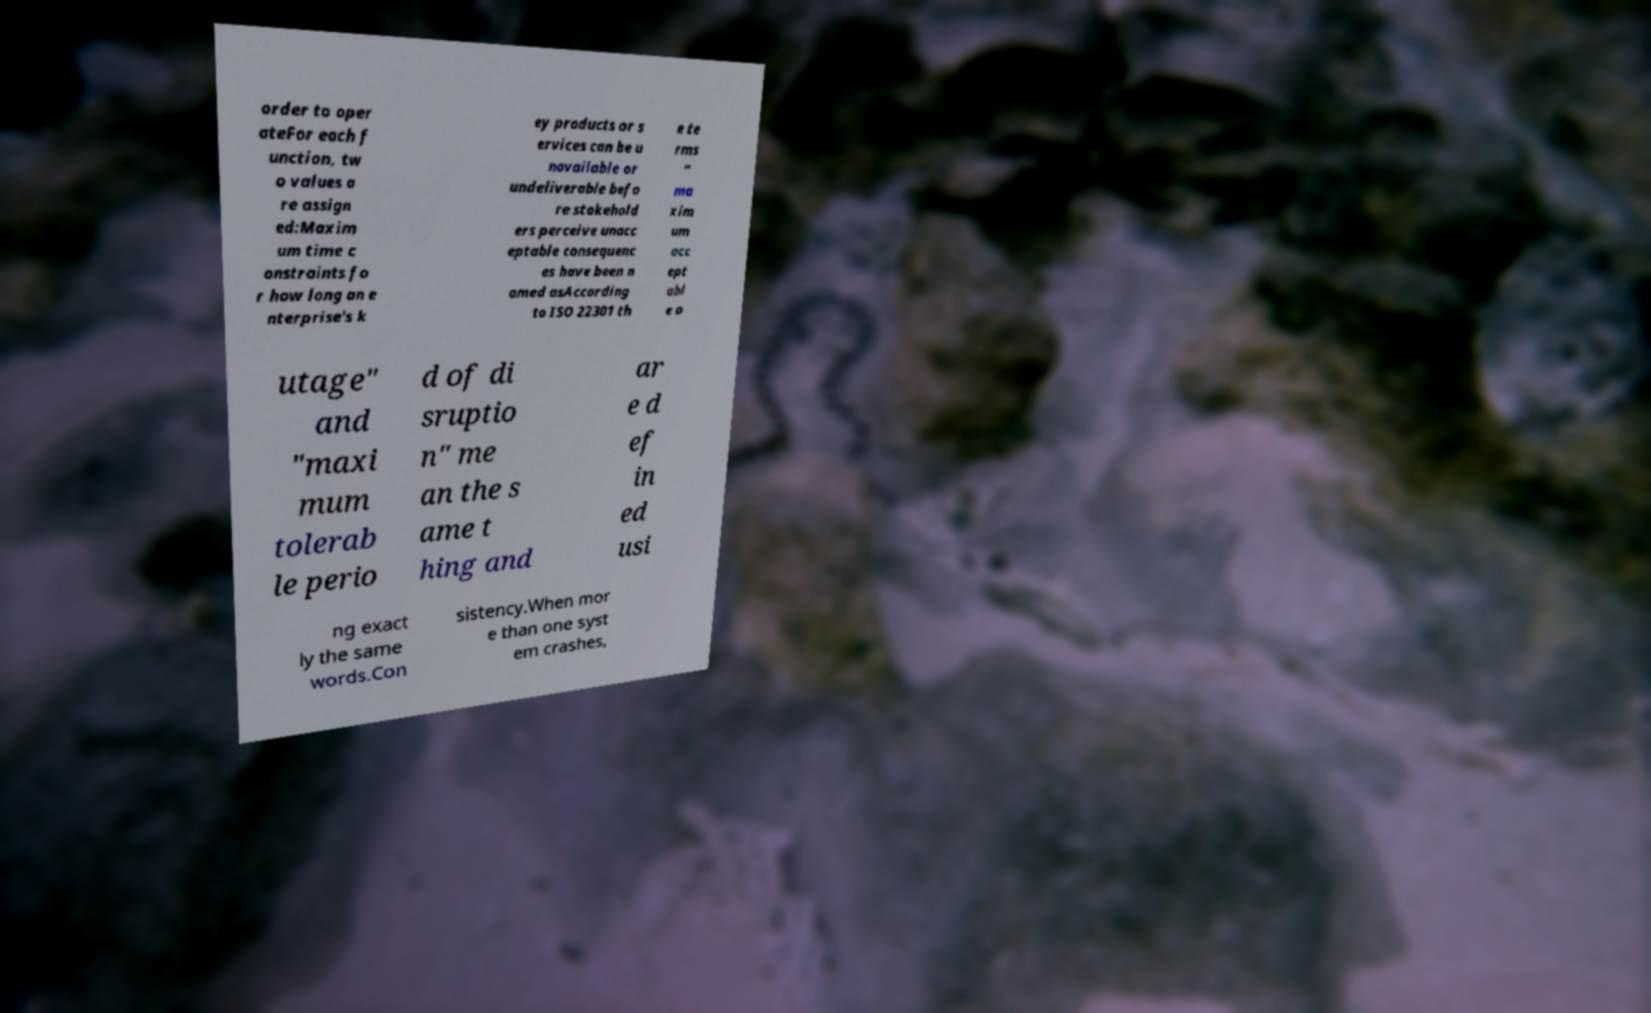Can you accurately transcribe the text from the provided image for me? order to oper ateFor each f unction, tw o values a re assign ed:Maxim um time c onstraints fo r how long an e nterprise's k ey products or s ervices can be u navailable or undeliverable befo re stakehold ers perceive unacc eptable consequenc es have been n amed asAccording to ISO 22301 th e te rms " ma xim um acc ept abl e o utage" and "maxi mum tolerab le perio d of di sruptio n" me an the s ame t hing and ar e d ef in ed usi ng exact ly the same words.Con sistency.When mor e than one syst em crashes, 